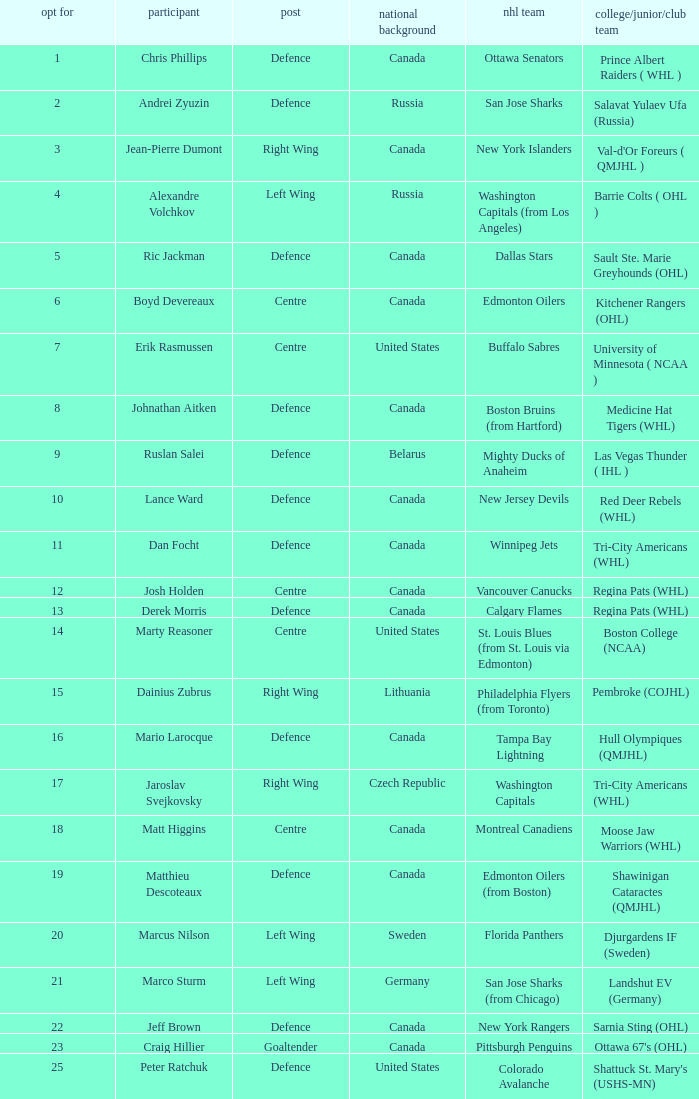What draft pick number was Ric Jackman? 5.0. 